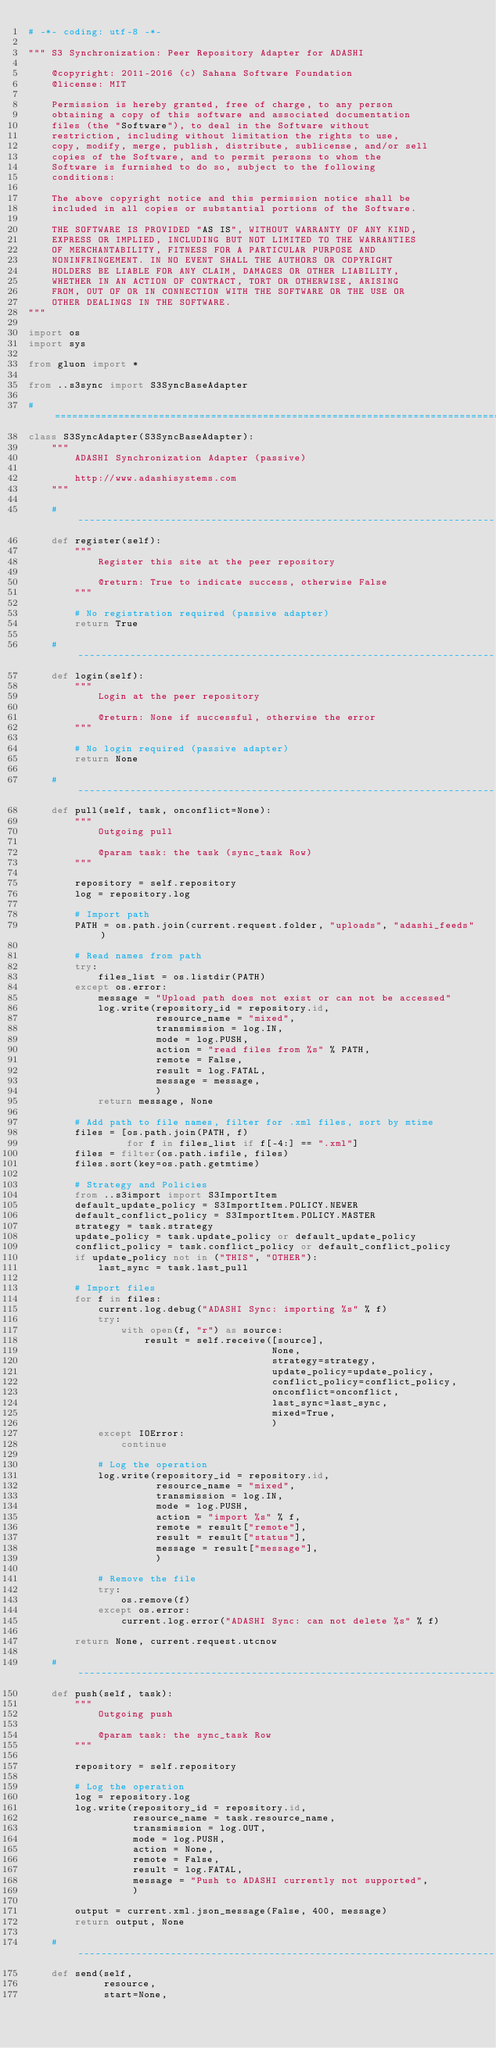<code> <loc_0><loc_0><loc_500><loc_500><_Python_># -*- coding: utf-8 -*-

""" S3 Synchronization: Peer Repository Adapter for ADASHI

    @copyright: 2011-2016 (c) Sahana Software Foundation
    @license: MIT

    Permission is hereby granted, free of charge, to any person
    obtaining a copy of this software and associated documentation
    files (the "Software"), to deal in the Software without
    restriction, including without limitation the rights to use,
    copy, modify, merge, publish, distribute, sublicense, and/or sell
    copies of the Software, and to permit persons to whom the
    Software is furnished to do so, subject to the following
    conditions:

    The above copyright notice and this permission notice shall be
    included in all copies or substantial portions of the Software.

    THE SOFTWARE IS PROVIDED "AS IS", WITHOUT WARRANTY OF ANY KIND,
    EXPRESS OR IMPLIED, INCLUDING BUT NOT LIMITED TO THE WARRANTIES
    OF MERCHANTABILITY, FITNESS FOR A PARTICULAR PURPOSE AND
    NONINFRINGEMENT. IN NO EVENT SHALL THE AUTHORS OR COPYRIGHT
    HOLDERS BE LIABLE FOR ANY CLAIM, DAMAGES OR OTHER LIABILITY,
    WHETHER IN AN ACTION OF CONTRACT, TORT OR OTHERWISE, ARISING
    FROM, OUT OF OR IN CONNECTION WITH THE SOFTWARE OR THE USE OR
    OTHER DEALINGS IN THE SOFTWARE.
"""

import os
import sys

from gluon import *

from ..s3sync import S3SyncBaseAdapter

# =============================================================================
class S3SyncAdapter(S3SyncBaseAdapter):
    """
        ADASHI Synchronization Adapter (passive)

        http://www.adashisystems.com
    """

    # -------------------------------------------------------------------------
    def register(self):
        """
            Register this site at the peer repository

            @return: True to indicate success, otherwise False
        """

        # No registration required (passive adapter)
        return True

    # -------------------------------------------------------------------------
    def login(self):
        """
            Login at the peer repository

            @return: None if successful, otherwise the error
        """

        # No login required (passive adapter)
        return None

    # -------------------------------------------------------------------------
    def pull(self, task, onconflict=None):
        """
            Outgoing pull

            @param task: the task (sync_task Row)
        """

        repository = self.repository
        log = repository.log

        # Import path
        PATH = os.path.join(current.request.folder, "uploads", "adashi_feeds")

        # Read names from path
        try:
            files_list = os.listdir(PATH)
        except os.error:
            message = "Upload path does not exist or can not be accessed"
            log.write(repository_id = repository.id,
                      resource_name = "mixed",
                      transmission = log.IN,
                      mode = log.PUSH,
                      action = "read files from %s" % PATH,
                      remote = False,
                      result = log.FATAL,
                      message = message,
                      )
            return message, None

        # Add path to file names, filter for .xml files, sort by mtime
        files = [os.path.join(PATH, f)
                 for f in files_list if f[-4:] == ".xml"]
        files = filter(os.path.isfile, files)
        files.sort(key=os.path.getmtime)

        # Strategy and Policies
        from ..s3import import S3ImportItem
        default_update_policy = S3ImportItem.POLICY.NEWER
        default_conflict_policy = S3ImportItem.POLICY.MASTER
        strategy = task.strategy
        update_policy = task.update_policy or default_update_policy
        conflict_policy = task.conflict_policy or default_conflict_policy
        if update_policy not in ("THIS", "OTHER"):
            last_sync = task.last_pull

        # Import files
        for f in files:
            current.log.debug("ADASHI Sync: importing %s" % f)
            try:
                with open(f, "r") as source:
                    result = self.receive([source],
                                          None,
                                          strategy=strategy,
                                          update_policy=update_policy,
                                          conflict_policy=conflict_policy,
                                          onconflict=onconflict,
                                          last_sync=last_sync,
                                          mixed=True,
                                          )
            except IOError:
                continue

            # Log the operation
            log.write(repository_id = repository.id,
                      resource_name = "mixed",
                      transmission = log.IN,
                      mode = log.PUSH,
                      action = "import %s" % f,
                      remote = result["remote"],
                      result = result["status"],
                      message = result["message"],
                      )

            # Remove the file
            try:
                os.remove(f)
            except os.error:
                current.log.error("ADASHI Sync: can not delete %s" % f)

        return None, current.request.utcnow

    # -------------------------------------------------------------------------
    def push(self, task):
        """
            Outgoing push

            @param task: the sync_task Row
        """

        repository = self.repository

        # Log the operation
        log = repository.log
        log.write(repository_id = repository.id,
                  resource_name = task.resource_name,
                  transmission = log.OUT,
                  mode = log.PUSH,
                  action = None,
                  remote = False,
                  result = log.FATAL,
                  message = "Push to ADASHI currently not supported",
                  )

        output = current.xml.json_message(False, 400, message)
        return output, None

    # -------------------------------------------------------------------------
    def send(self,
             resource,
             start=None,</code> 